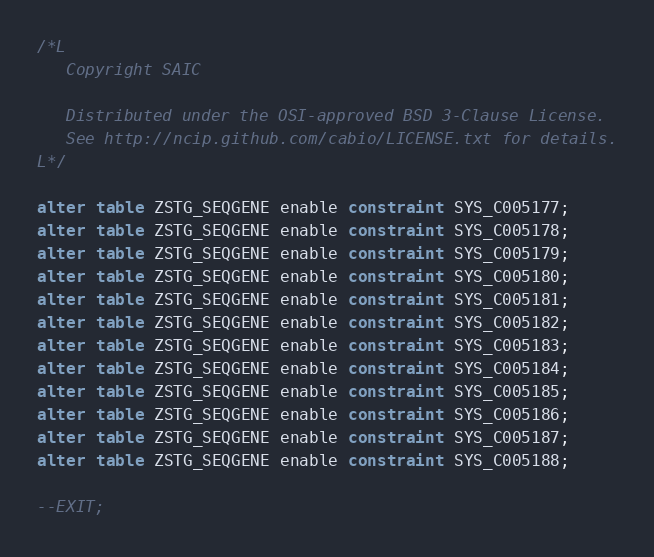Convert code to text. <code><loc_0><loc_0><loc_500><loc_500><_SQL_>/*L
   Copyright SAIC

   Distributed under the OSI-approved BSD 3-Clause License.
   See http://ncip.github.com/cabio/LICENSE.txt for details.
L*/

alter table ZSTG_SEQGENE enable constraint SYS_C005177;
alter table ZSTG_SEQGENE enable constraint SYS_C005178;
alter table ZSTG_SEQGENE enable constraint SYS_C005179;
alter table ZSTG_SEQGENE enable constraint SYS_C005180;
alter table ZSTG_SEQGENE enable constraint SYS_C005181;
alter table ZSTG_SEQGENE enable constraint SYS_C005182;
alter table ZSTG_SEQGENE enable constraint SYS_C005183;
alter table ZSTG_SEQGENE enable constraint SYS_C005184;
alter table ZSTG_SEQGENE enable constraint SYS_C005185;
alter table ZSTG_SEQGENE enable constraint SYS_C005186;
alter table ZSTG_SEQGENE enable constraint SYS_C005187;
alter table ZSTG_SEQGENE enable constraint SYS_C005188;

--EXIT;
</code> 